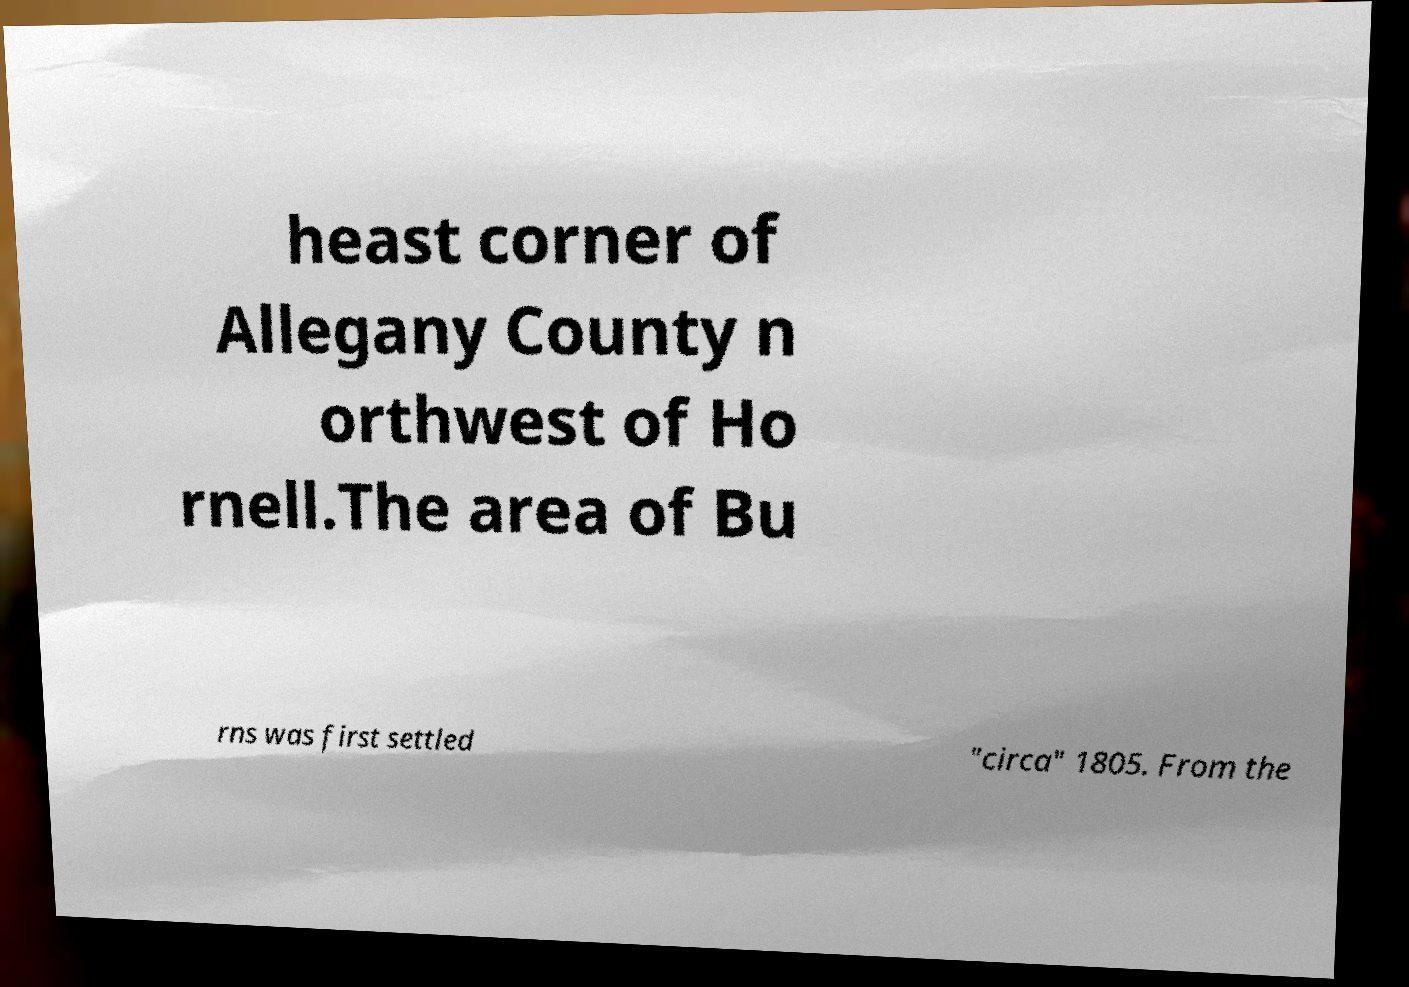Can you read and provide the text displayed in the image?This photo seems to have some interesting text. Can you extract and type it out for me? heast corner of Allegany County n orthwest of Ho rnell.The area of Bu rns was first settled "circa" 1805. From the 